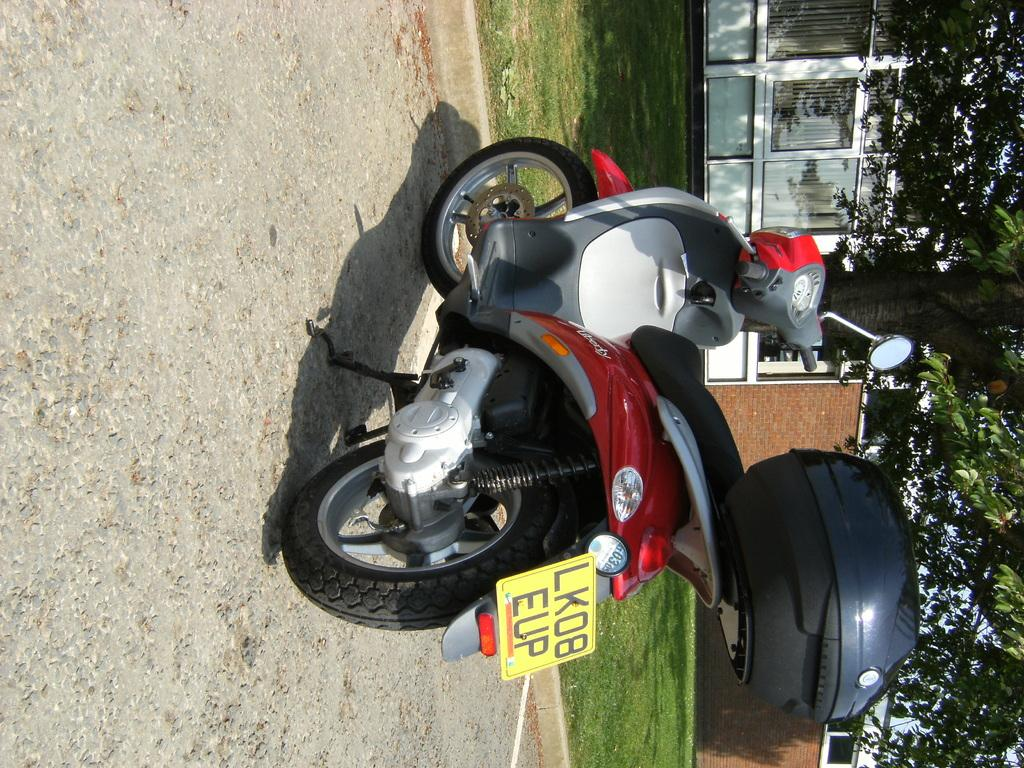What type of vehicle is in the image? There is a red bike in the image. What can be seen in the background of the image? There are trees and a building in the background of the image. What color are the trees in the image? The trees are green. What color is the building in the image? The building is white. What feature can be observed on the building in the image? The building has glass windows. Where is the quill located in the image? There is no quill present in the image. What type of drawer can be seen in the image? There is no drawer present in the image. 